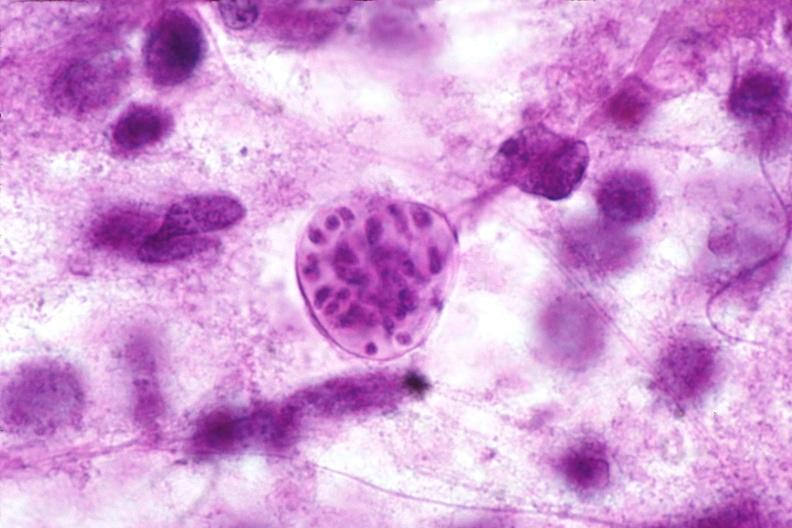where is this?
Answer the question using a single word or phrase. Nervous 